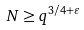<formula> <loc_0><loc_0><loc_500><loc_500>N \geq q ^ { 3 / 4 + \varepsilon }</formula> 